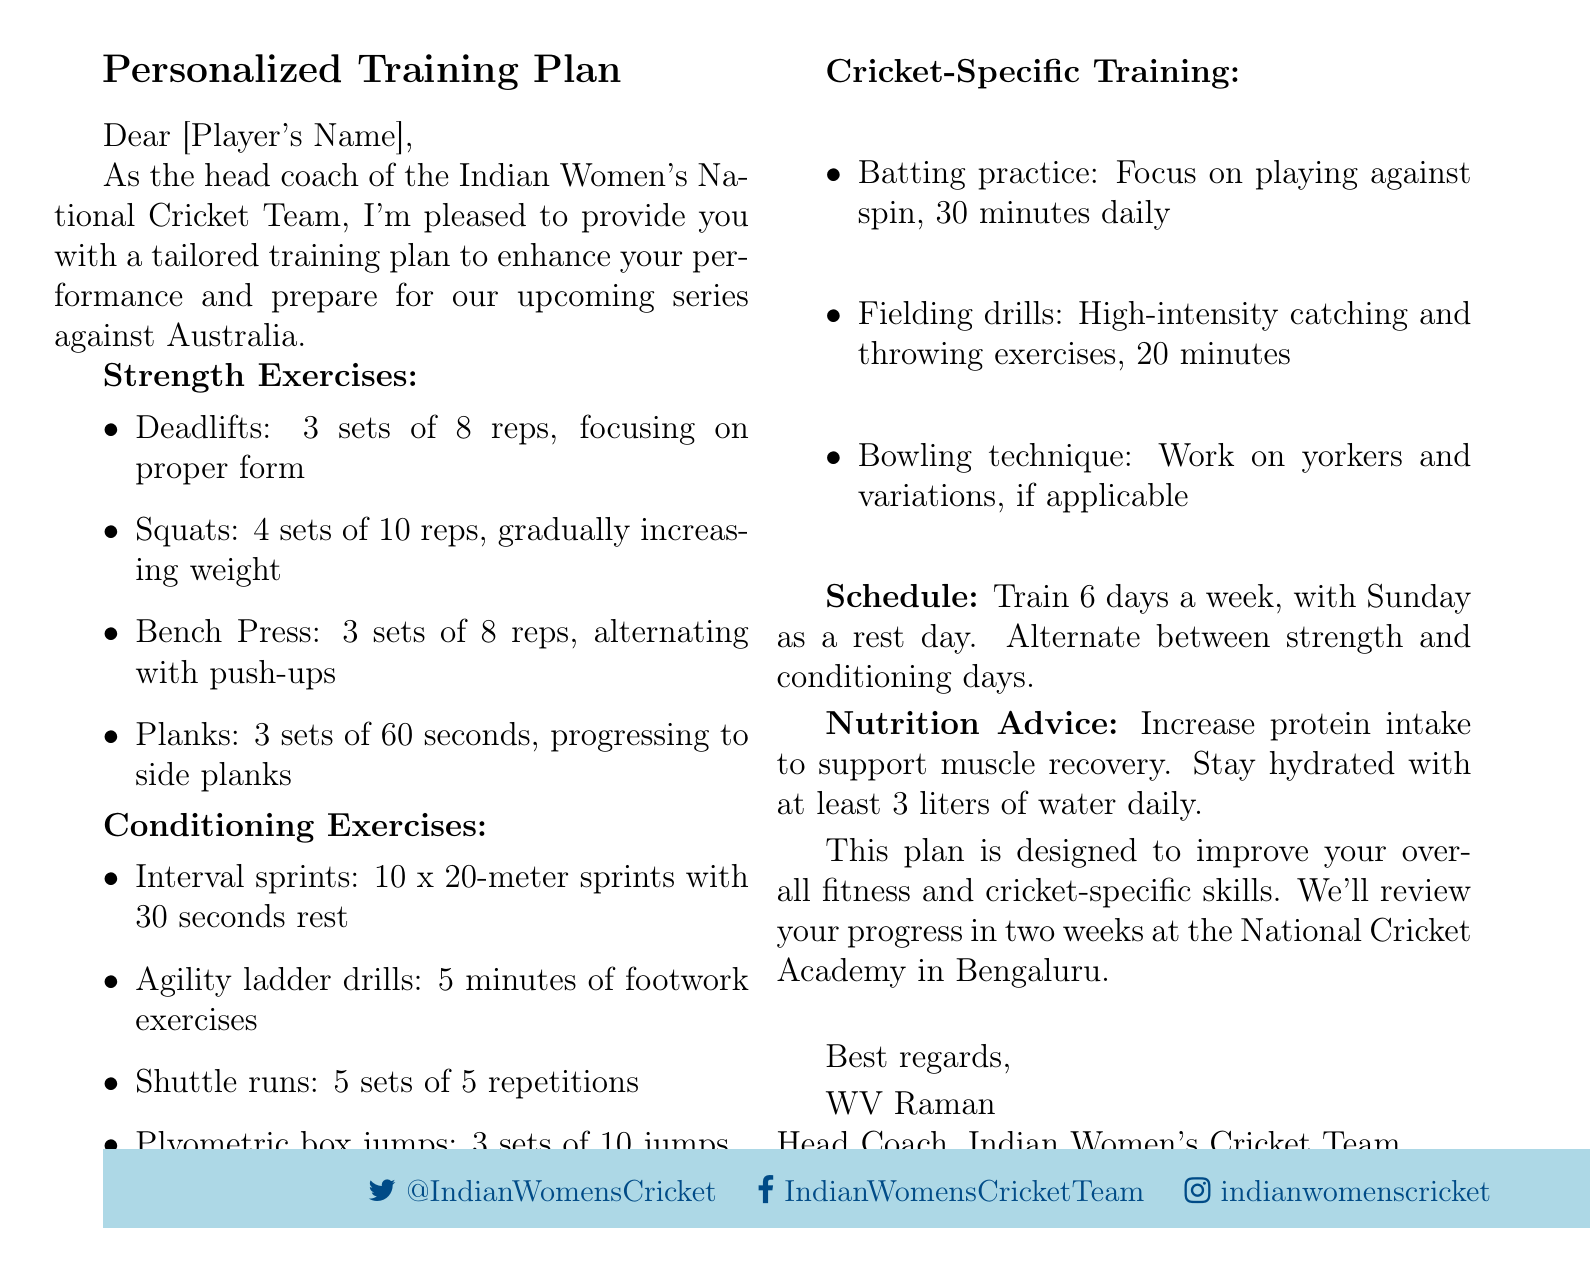what is the subject of the email? The subject line states the main topic of the email, which is the training plan for the team.
Answer: Personalized Training Plan for Indian Women's Cricket Team who is the sender of the email? The signature at the end of the email identifies the person sending the message.
Answer: WV Raman how many days a week should the players train? The training schedule specifies the number of days dedicated to training.
Answer: 6 days what is the rest day in the training schedule? The document clearly indicates which day is designated for rest.
Answer: Sunday how many sets of planks are recommended? The strength exercises section includes the number of sets and duration for planks.
Answer: 3 sets what should players increase in their diet according to the nutrition advice? The nutrition advice section highlights a specific dietary increase for recovery.
Answer: protein intake how many minutes should the batting practice focus on spin? The cricket-specific training section specifies the duration for batting practice against spin.
Answer: 30 minutes what type of jumps are included in the conditioning exercises? The conditioning exercises list a particular kind of jump that is instructed.
Answer: Plyometric box jumps what is the focus of the fielding drills? The cricket-specific training details the primary objective of the fielding drills.
Answer: High-intensity catching and throwing exercises 